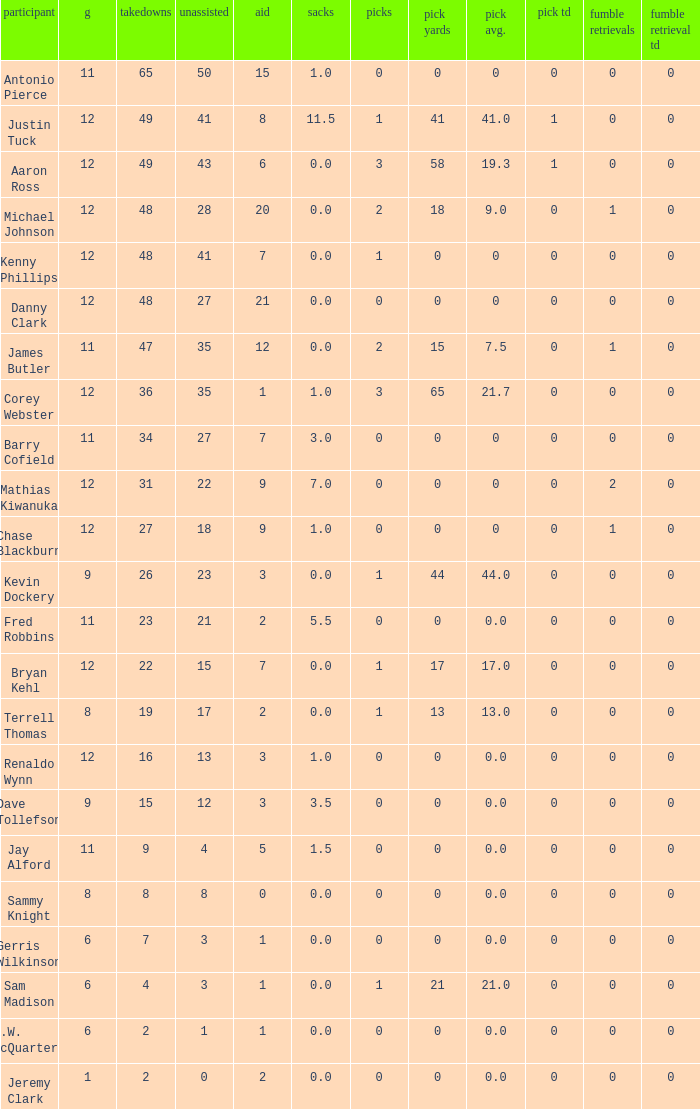Name the most tackles for 3.5 sacks 15.0. 